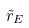<formula> <loc_0><loc_0><loc_500><loc_500>\tilde { r } _ { E }</formula> 